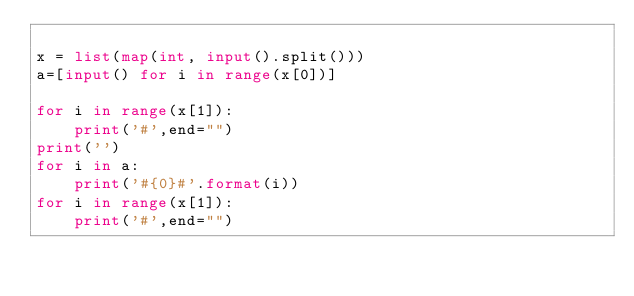<code> <loc_0><loc_0><loc_500><loc_500><_Python_>
x = list(map(int, input().split()))
a=[input() for i in range(x[0])]

for i in range(x[1]):
    print('#',end="")
print('')
for i in a:
    print('#{0}#'.format(i))
for i in range(x[1]):
    print('#',end="")


</code> 